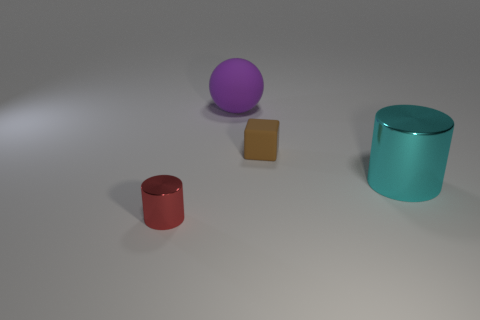Imagine these objects are part of a game. What could be the rules involving these shapes and colors? In a game scenario, one could envision a rule where each object must be placed in a corresponding outline based on its shape and color. For instance, players might need to match objects to silhouette guides on a board, with points awarded for speed and accuracy. The different colors and shapes could represent various levels of difficulty or point values. 